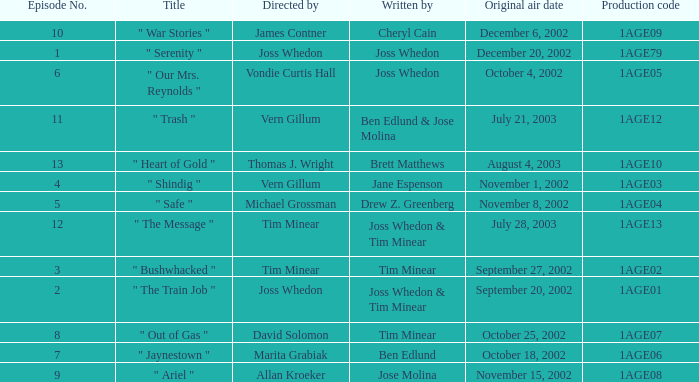What is the production code for the episode written by Drew Z. Greenberg? 1AGE04. 